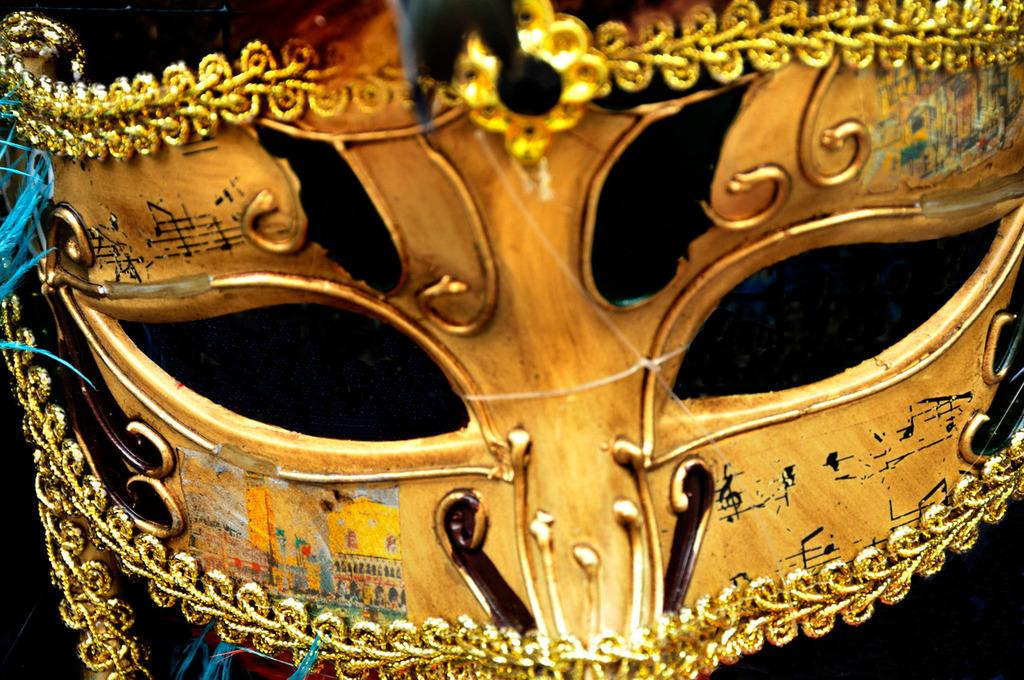What type of object is depicted in the image? The object is an eye mask. What colors are used in the design of the eye mask? The eye mask is in golden and black color. Are there any decorative elements on the eye mask? Yes, there is golden lace on the border of the eye mask. What can be observed about the back of the eye mask? The back of the eye mask is dark. What type of appliance is used to sew the needle onto the eye mask? There is no appliance or needle present on the eye mask in the image. What type of drug is being administered through the eye mask in the image? There is no drug or any medical application associated with the eye mask in the image. 